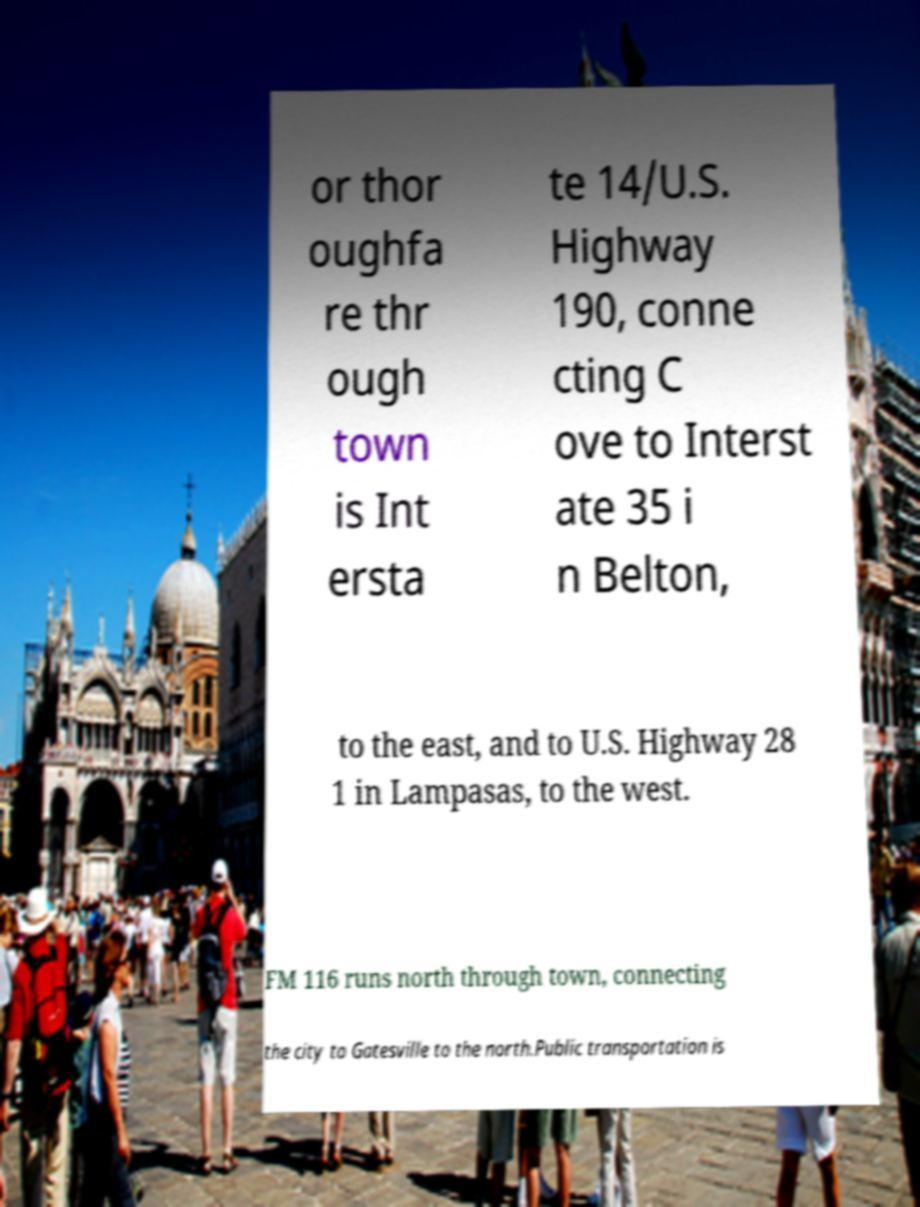Can you accurately transcribe the text from the provided image for me? or thor oughfa re thr ough town is Int ersta te 14/U.S. Highway 190, conne cting C ove to Interst ate 35 i n Belton, to the east, and to U.S. Highway 28 1 in Lampasas, to the west. FM 116 runs north through town, connecting the city to Gatesville to the north.Public transportation is 